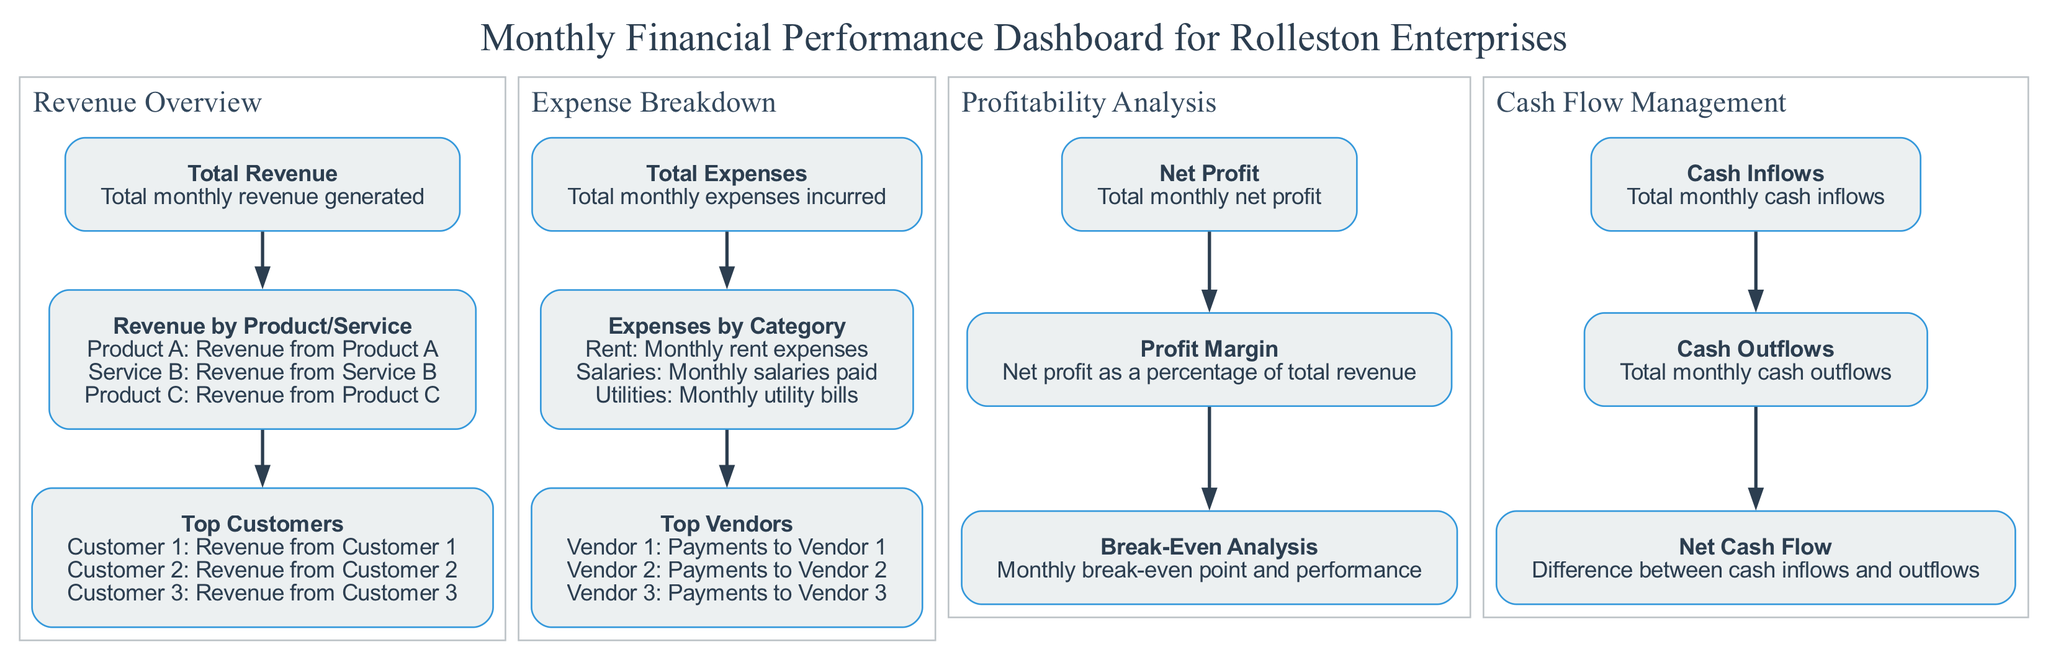What is the total monthly revenue generated? The block titled "Total Revenue" in the "Revenue Overview" section specifies the total amount of revenue for the month. This value is directly listed under its title.
Answer: Total monthly revenue generated Which product generated the most revenue? To find this, one needs to look at the block labeled "Revenue by Product/Service" within the "Revenue Overview" section and determine which product has the highest revenue among the listed values.
Answer: Revenue from Product A What are the categories of expenses listed? The block titled "Expenses by Category" in the "Expense Breakdown" section indicates the different expense categories outlined for the month. Each category is listed under this block.
Answer: Rent, Salaries, Utilities What is the total amount of monthly net profit? The "Net Profit" block in the "Profitability Analysis" section provides the total amount of net profit for the month. This figure is specifically stated within this block.
Answer: Total monthly net profit What relationship exists between total cash inflows and outflows? The "Cash Inflows" and "Cash Outflows" blocks in the "Cash Flow Management" section illustrate the amounts of cash coming in and going out. The net cash flow is determined by the difference between these two values.
Answer: Difference between inflows and outflows What does the break-even analysis provide? The block titled "Break-Even Analysis" in the "Profitability Analysis" section describes the monthly break-even point and performance metrics to understand when revenue equals expenses.
Answer: Monthly break-even point and performance How many vendors are listed in the top vendors? The block titled "Top Vendors" in the "Expense Breakdown" section lists three vendors, which can be counted to determine the total number mentioned.
Answer: Three vendors Which section contains profitability metrics? The section that focuses on profitability metrics is clearly labeled as "Profitability Analysis" and includes blocks that relate to net profit, profit margin, and break-even analysis.
Answer: Profitability Analysis How many sections are there in total on the dashboard? By counting the distinct groupings of the blocks within the entire diagram, one can identify that there are four main sections in the dashboard.
Answer: Four sections 